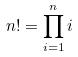<formula> <loc_0><loc_0><loc_500><loc_500>n ! = \prod _ { i = 1 } ^ { n } i</formula> 